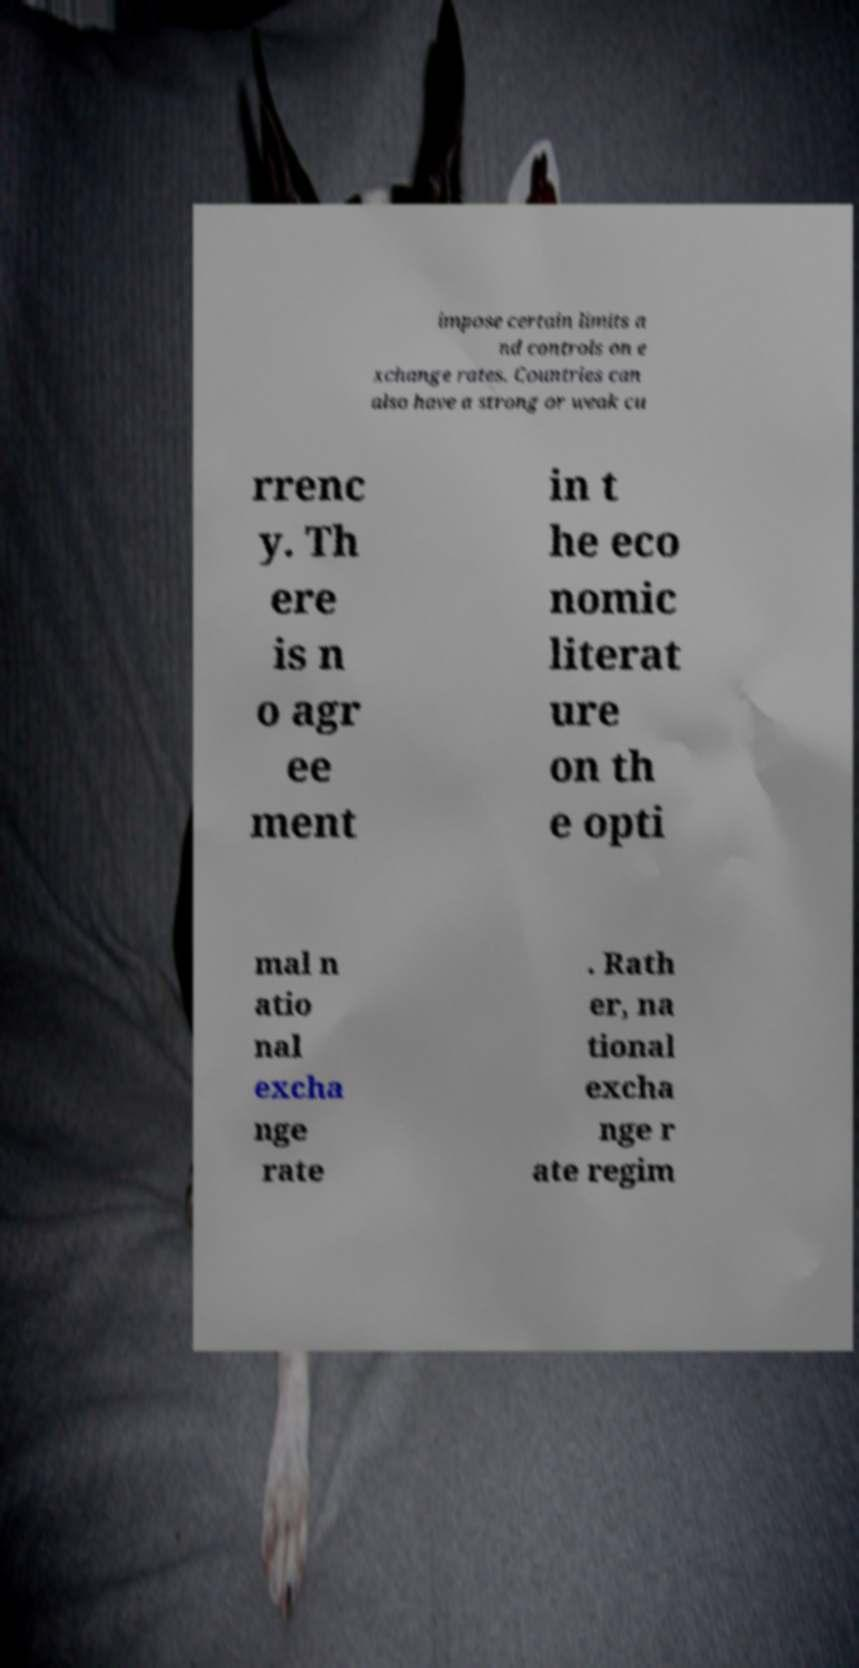Could you extract and type out the text from this image? impose certain limits a nd controls on e xchange rates. Countries can also have a strong or weak cu rrenc y. Th ere is n o agr ee ment in t he eco nomic literat ure on th e opti mal n atio nal excha nge rate . Rath er, na tional excha nge r ate regim 